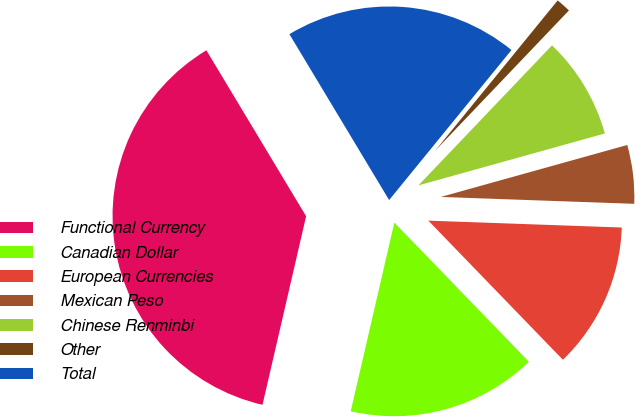Convert chart to OTSL. <chart><loc_0><loc_0><loc_500><loc_500><pie_chart><fcel>Functional Currency<fcel>Canadian Dollar<fcel>European Currencies<fcel>Mexican Peso<fcel>Chinese Renminbi<fcel>Other<fcel>Total<nl><fcel>37.77%<fcel>15.85%<fcel>12.2%<fcel>4.89%<fcel>8.55%<fcel>1.24%<fcel>19.5%<nl></chart> 